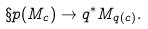Convert formula to latex. <formula><loc_0><loc_0><loc_500><loc_500>\S p ( M _ { c } ) \to q ^ { * } M _ { q ( c ) } .</formula> 